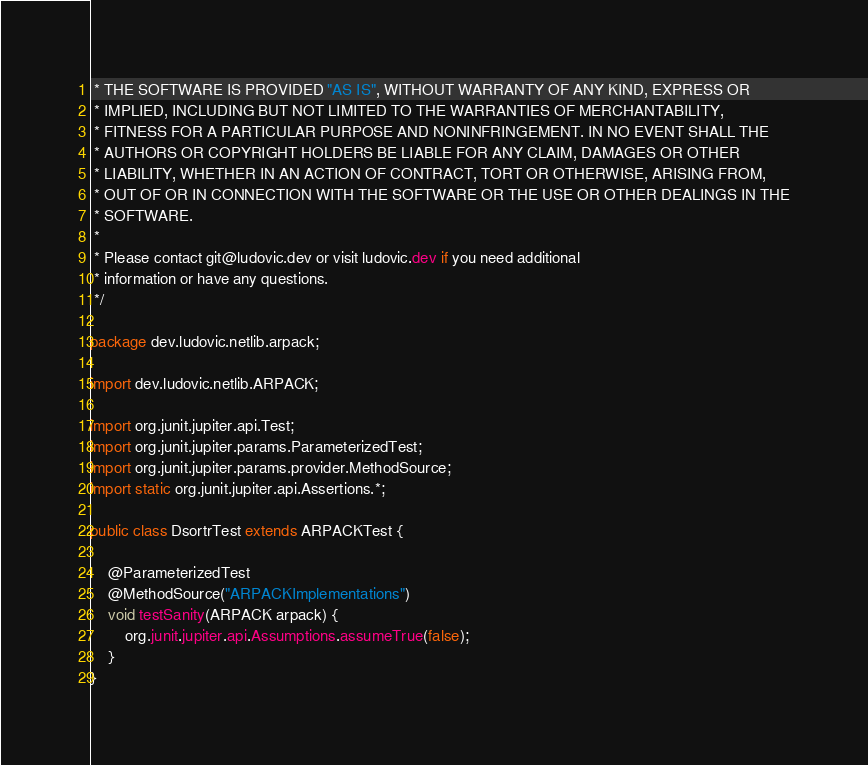Convert code to text. <code><loc_0><loc_0><loc_500><loc_500><_Java_> * THE SOFTWARE IS PROVIDED "AS IS", WITHOUT WARRANTY OF ANY KIND, EXPRESS OR
 * IMPLIED, INCLUDING BUT NOT LIMITED TO THE WARRANTIES OF MERCHANTABILITY,
 * FITNESS FOR A PARTICULAR PURPOSE AND NONINFRINGEMENT. IN NO EVENT SHALL THE
 * AUTHORS OR COPYRIGHT HOLDERS BE LIABLE FOR ANY CLAIM, DAMAGES OR OTHER
 * LIABILITY, WHETHER IN AN ACTION OF CONTRACT, TORT OR OTHERWISE, ARISING FROM,
 * OUT OF OR IN CONNECTION WITH THE SOFTWARE OR THE USE OR OTHER DEALINGS IN THE
 * SOFTWARE.
 *
 * Please contact git@ludovic.dev or visit ludovic.dev if you need additional
 * information or have any questions.
 */

package dev.ludovic.netlib.arpack;

import dev.ludovic.netlib.ARPACK;

import org.junit.jupiter.api.Test;
import org.junit.jupiter.params.ParameterizedTest;
import org.junit.jupiter.params.provider.MethodSource;
import static org.junit.jupiter.api.Assertions.*;

public class DsortrTest extends ARPACKTest {

    @ParameterizedTest
    @MethodSource("ARPACKImplementations")
    void testSanity(ARPACK arpack) {
        org.junit.jupiter.api.Assumptions.assumeTrue(false);
    }
}
</code> 